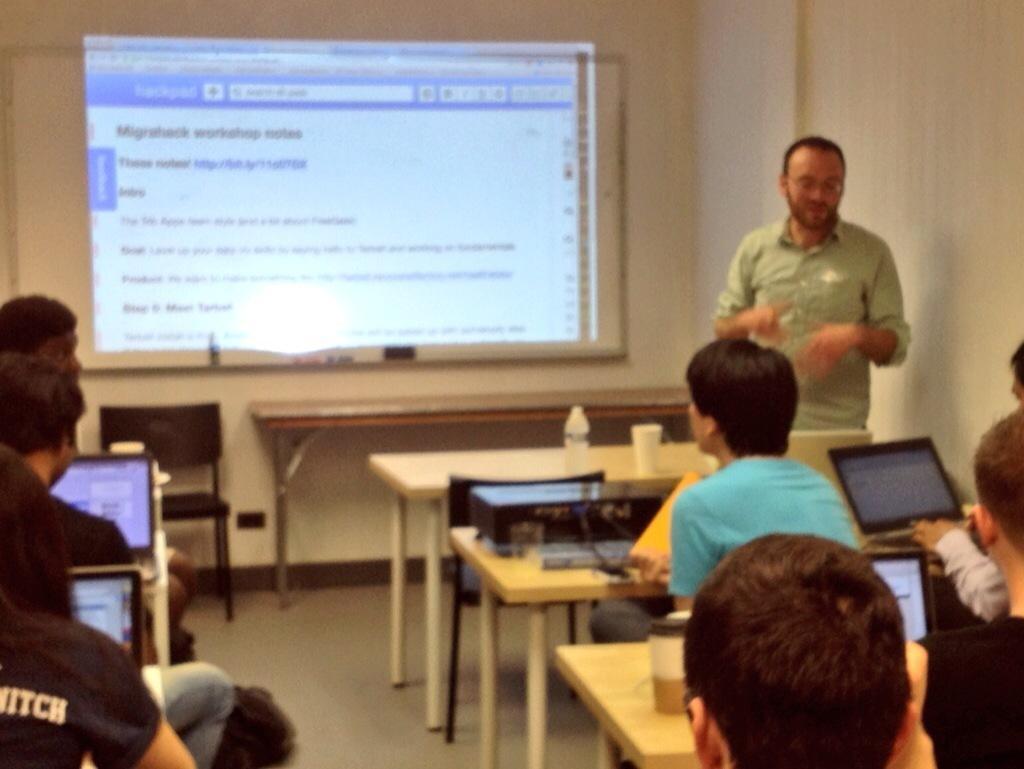Could you give a brief overview of what you see in this image? This is a classroom picture. Here we can see table , chairs. On the tables we can see bottle and glass. We can see students sitting on chairs. Here we can see one man standing in front of a table. He wore spectacles. This is a screen over a wall. 